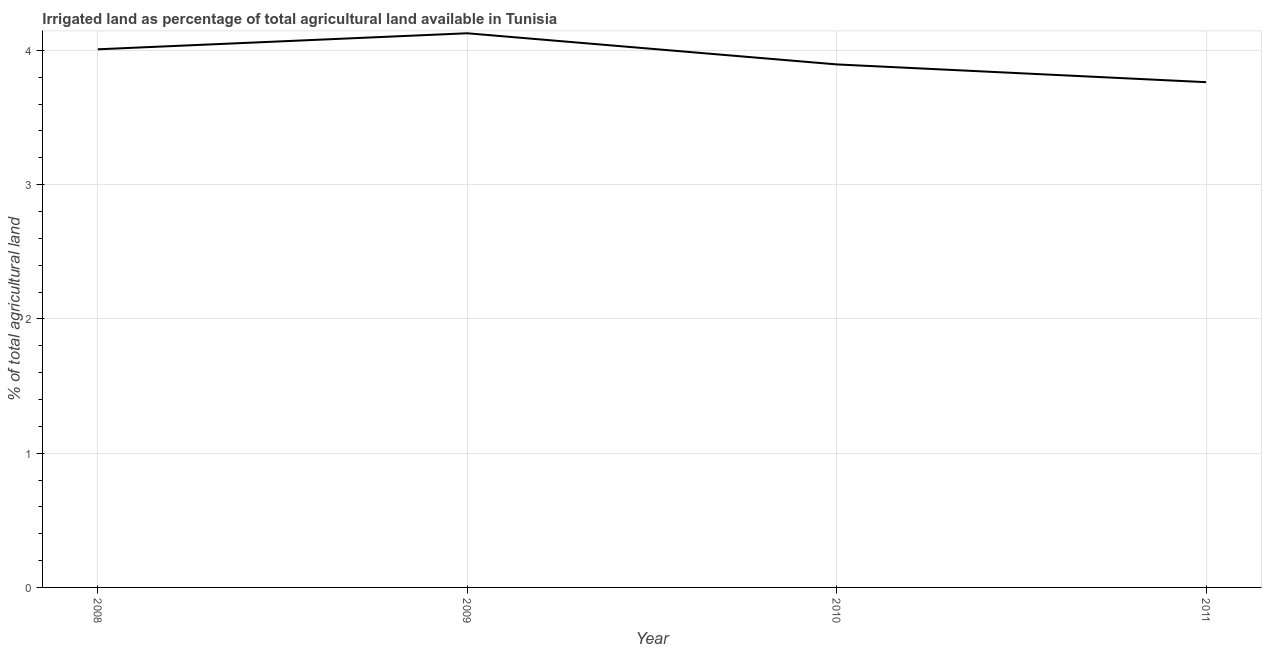What is the percentage of agricultural irrigated land in 2010?
Your answer should be very brief. 3.9. Across all years, what is the maximum percentage of agricultural irrigated land?
Give a very brief answer. 4.13. Across all years, what is the minimum percentage of agricultural irrigated land?
Ensure brevity in your answer.  3.76. What is the sum of the percentage of agricultural irrigated land?
Provide a short and direct response. 15.79. What is the difference between the percentage of agricultural irrigated land in 2009 and 2010?
Offer a terse response. 0.23. What is the average percentage of agricultural irrigated land per year?
Make the answer very short. 3.95. What is the median percentage of agricultural irrigated land?
Offer a terse response. 3.95. What is the ratio of the percentage of agricultural irrigated land in 2008 to that in 2010?
Your response must be concise. 1.03. What is the difference between the highest and the second highest percentage of agricultural irrigated land?
Give a very brief answer. 0.12. What is the difference between the highest and the lowest percentage of agricultural irrigated land?
Make the answer very short. 0.36. In how many years, is the percentage of agricultural irrigated land greater than the average percentage of agricultural irrigated land taken over all years?
Keep it short and to the point. 2. Does the percentage of agricultural irrigated land monotonically increase over the years?
Provide a short and direct response. No. How many lines are there?
Your response must be concise. 1. Are the values on the major ticks of Y-axis written in scientific E-notation?
Your answer should be very brief. No. What is the title of the graph?
Keep it short and to the point. Irrigated land as percentage of total agricultural land available in Tunisia. What is the label or title of the X-axis?
Your answer should be very brief. Year. What is the label or title of the Y-axis?
Ensure brevity in your answer.  % of total agricultural land. What is the % of total agricultural land in 2008?
Make the answer very short. 4.01. What is the % of total agricultural land of 2009?
Offer a terse response. 4.13. What is the % of total agricultural land of 2010?
Ensure brevity in your answer.  3.9. What is the % of total agricultural land of 2011?
Provide a short and direct response. 3.76. What is the difference between the % of total agricultural land in 2008 and 2009?
Your answer should be very brief. -0.12. What is the difference between the % of total agricultural land in 2008 and 2010?
Offer a terse response. 0.11. What is the difference between the % of total agricultural land in 2008 and 2011?
Offer a very short reply. 0.24. What is the difference between the % of total agricultural land in 2009 and 2010?
Offer a very short reply. 0.23. What is the difference between the % of total agricultural land in 2009 and 2011?
Your answer should be compact. 0.36. What is the difference between the % of total agricultural land in 2010 and 2011?
Ensure brevity in your answer.  0.13. What is the ratio of the % of total agricultural land in 2008 to that in 2009?
Make the answer very short. 0.97. What is the ratio of the % of total agricultural land in 2008 to that in 2011?
Offer a very short reply. 1.06. What is the ratio of the % of total agricultural land in 2009 to that in 2010?
Give a very brief answer. 1.06. What is the ratio of the % of total agricultural land in 2009 to that in 2011?
Ensure brevity in your answer.  1.1. What is the ratio of the % of total agricultural land in 2010 to that in 2011?
Offer a terse response. 1.03. 